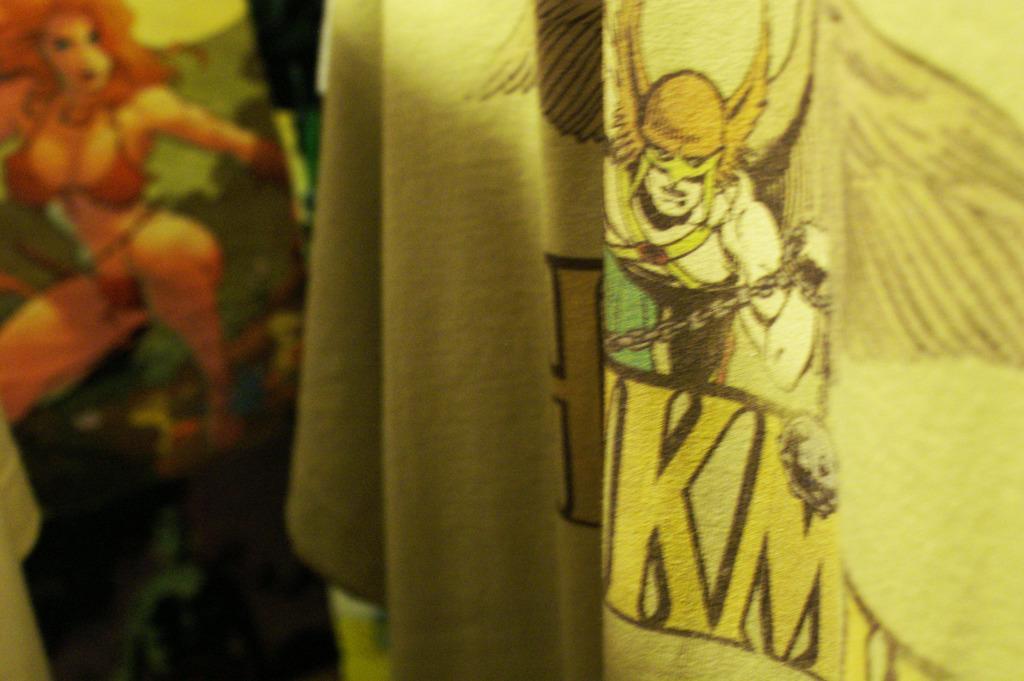Can you describe this image briefly? In this picture there are two clothes on the right and left side of the image, on which there are cartoon characters. 